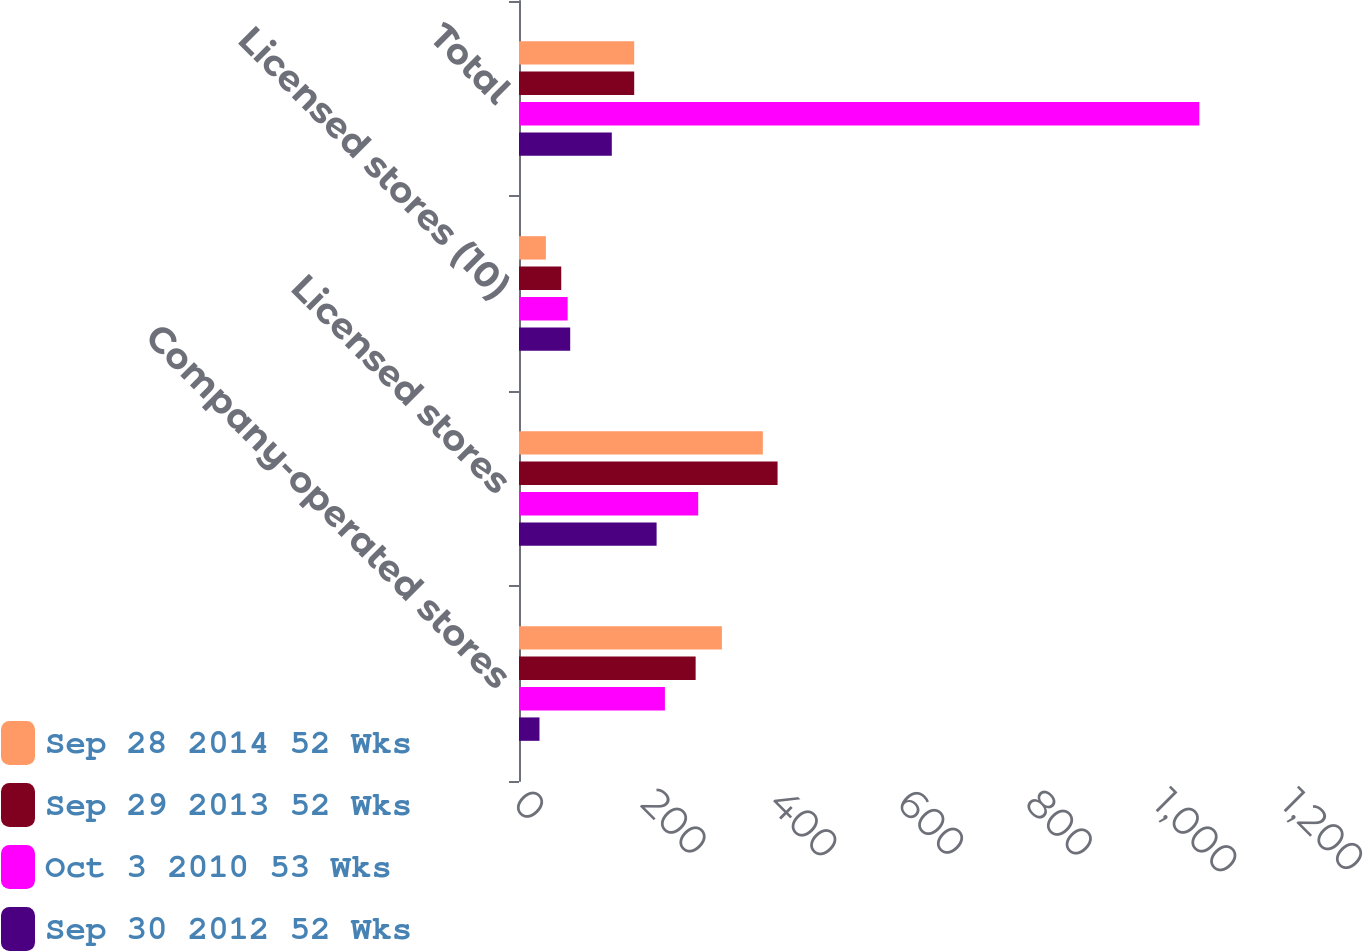Convert chart. <chart><loc_0><loc_0><loc_500><loc_500><stacked_bar_chart><ecel><fcel>Company-operated stores<fcel>Licensed stores<fcel>Licensed stores (10)<fcel>Total<nl><fcel>Sep 28 2014 52 Wks<fcel>317<fcel>381<fcel>42<fcel>180<nl><fcel>Sep 29 2013 52 Wks<fcel>276<fcel>404<fcel>66<fcel>180<nl><fcel>Oct 3 2010 53 Wks<fcel>228<fcel>280<fcel>76<fcel>1063<nl><fcel>Sep 30 2012 52 Wks<fcel>32<fcel>215<fcel>80<fcel>145<nl></chart> 